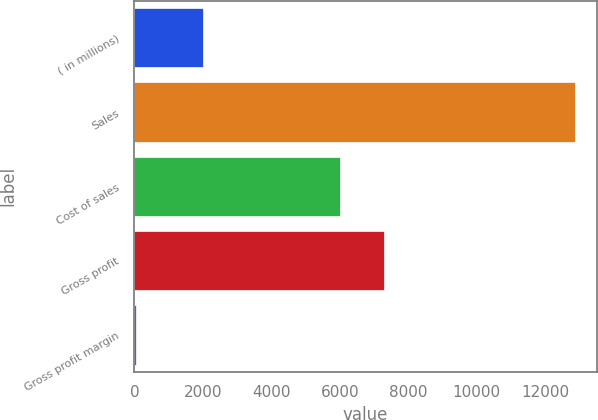<chart> <loc_0><loc_0><loc_500><loc_500><bar_chart><fcel>( in millions)<fcel>Sales<fcel>Cost of sales<fcel>Gross profit<fcel>Gross profit margin<nl><fcel>2014<fcel>12866.9<fcel>6017.4<fcel>7298.77<fcel>53.2<nl></chart> 